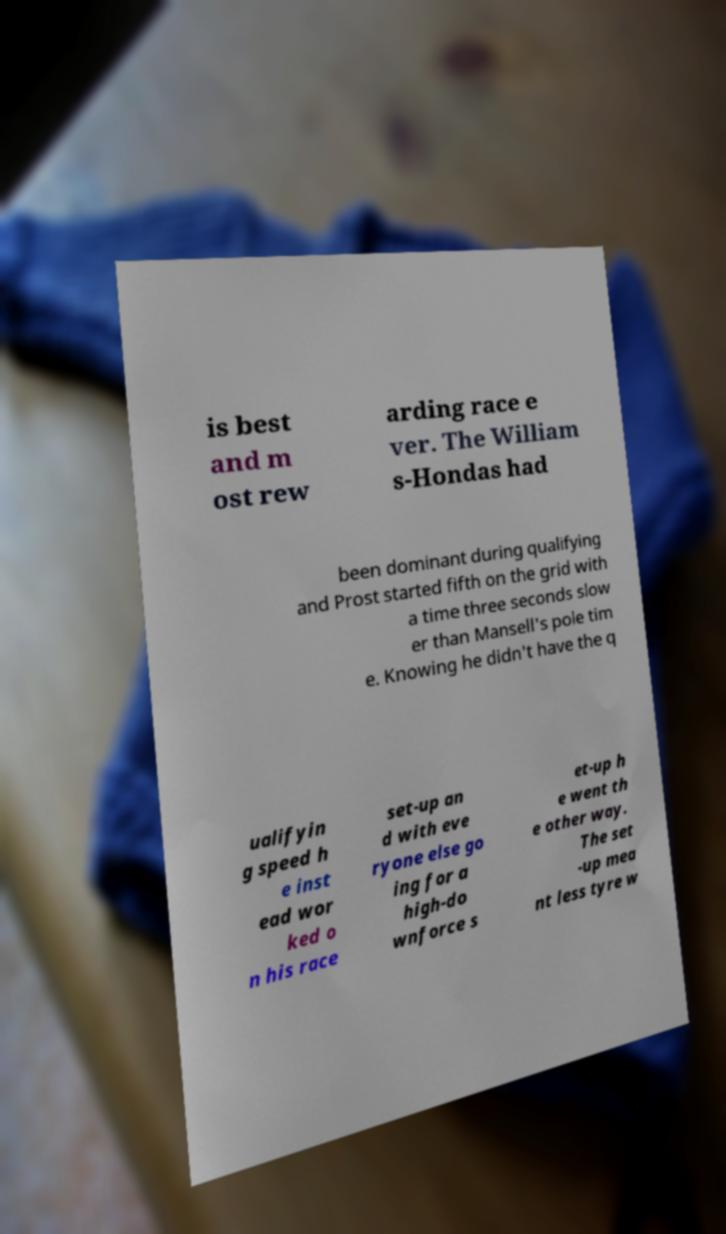Can you read and provide the text displayed in the image?This photo seems to have some interesting text. Can you extract and type it out for me? is best and m ost rew arding race e ver. The William s-Hondas had been dominant during qualifying and Prost started fifth on the grid with a time three seconds slow er than Mansell's pole tim e. Knowing he didn't have the q ualifyin g speed h e inst ead wor ked o n his race set-up an d with eve ryone else go ing for a high-do wnforce s et-up h e went th e other way. The set -up mea nt less tyre w 